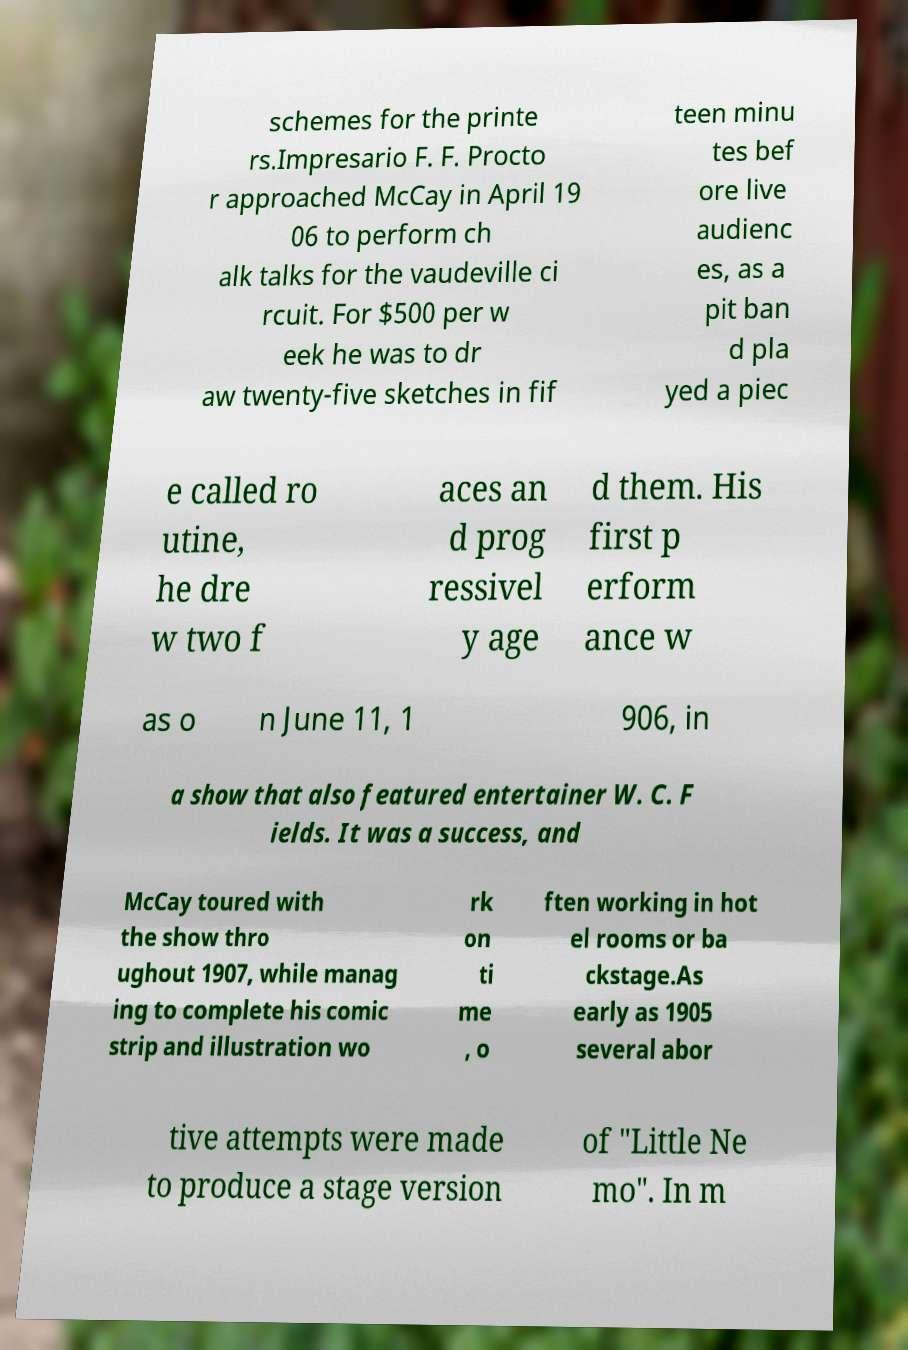Could you extract and type out the text from this image? schemes for the printe rs.Impresario F. F. Procto r approached McCay in April 19 06 to perform ch alk talks for the vaudeville ci rcuit. For $500 per w eek he was to dr aw twenty-five sketches in fif teen minu tes bef ore live audienc es, as a pit ban d pla yed a piec e called ro utine, he dre w two f aces an d prog ressivel y age d them. His first p erform ance w as o n June 11, 1 906, in a show that also featured entertainer W. C. F ields. It was a success, and McCay toured with the show thro ughout 1907, while manag ing to complete his comic strip and illustration wo rk on ti me , o ften working in hot el rooms or ba ckstage.As early as 1905 several abor tive attempts were made to produce a stage version of "Little Ne mo". In m 